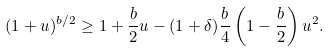<formula> <loc_0><loc_0><loc_500><loc_500>( 1 + u ) ^ { b / 2 } \geq 1 + \frac { b } { 2 } u - ( 1 + \delta ) \frac { b } { 4 } \left ( 1 - \frac { b } { 2 } \right ) u ^ { 2 } .</formula> 